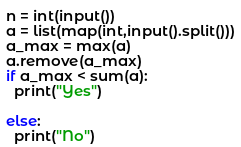Convert code to text. <code><loc_0><loc_0><loc_500><loc_500><_Python_>n = int(input())
a = list(map(int,input().split()))
a_max = max(a)
a.remove(a_max)
if a_max < sum(a):
  print("Yes")
  
else:
  print("No")</code> 